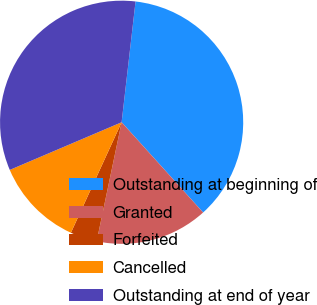<chart> <loc_0><loc_0><loc_500><loc_500><pie_chart><fcel>Outstanding at beginning of<fcel>Granted<fcel>Forfeited<fcel>Cancelled<fcel>Outstanding at end of year<nl><fcel>36.48%<fcel>14.98%<fcel>3.56%<fcel>11.74%<fcel>33.24%<nl></chart> 